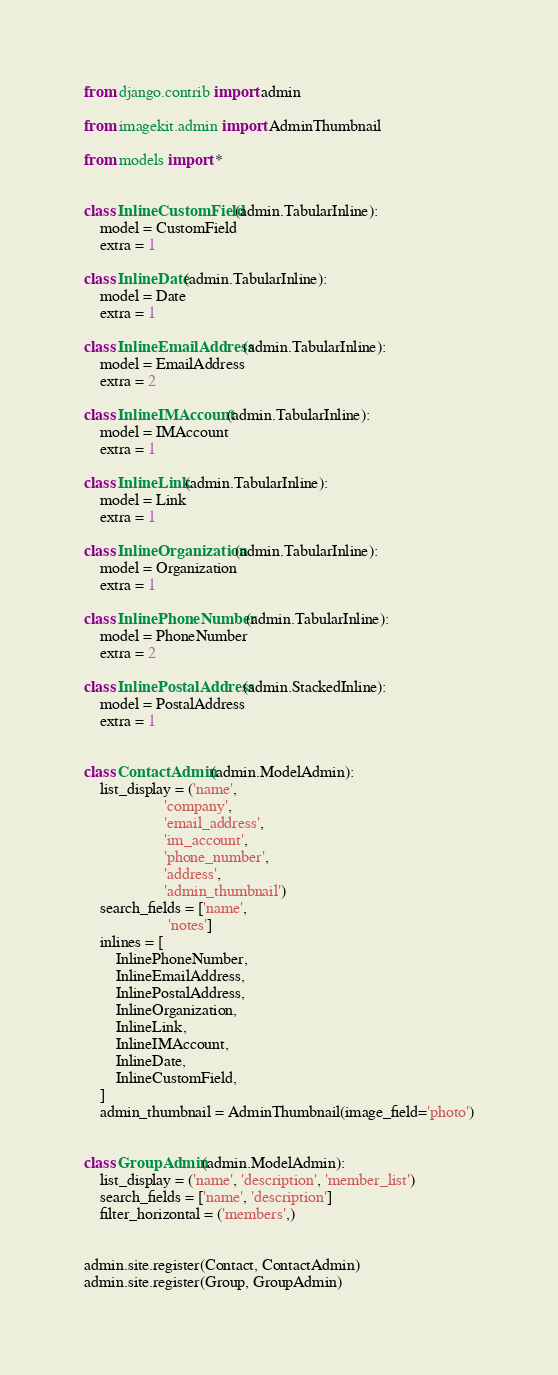Convert code to text. <code><loc_0><loc_0><loc_500><loc_500><_Python_>from django.contrib import admin

from imagekit.admin import AdminThumbnail

from models import *


class InlineCustomField(admin.TabularInline):
    model = CustomField
    extra = 1

class InlineDate(admin.TabularInline):
    model = Date
    extra = 1

class InlineEmailAddress(admin.TabularInline):
    model = EmailAddress
    extra = 2

class InlineIMAccount(admin.TabularInline):
    model = IMAccount
    extra = 1

class InlineLink(admin.TabularInline):
    model = Link
    extra = 1

class InlineOrganization(admin.TabularInline):
    model = Organization
    extra = 1

class InlinePhoneNumber(admin.TabularInline):
    model = PhoneNumber
    extra = 2

class InlinePostalAddress(admin.StackedInline):
    model = PostalAddress
    extra = 1


class ContactAdmin(admin.ModelAdmin):
    list_display = ('name',
                    'company',
                    'email_address',
                    'im_account',
                    'phone_number',
                    'address',
                    'admin_thumbnail')
    search_fields = ['name',
                     'notes']
    inlines = [
        InlinePhoneNumber,
        InlineEmailAddress,
        InlinePostalAddress,
        InlineOrganization,
        InlineLink,
        InlineIMAccount,
        InlineDate,
        InlineCustomField,
    ]
    admin_thumbnail = AdminThumbnail(image_field='photo')


class GroupAdmin(admin.ModelAdmin):
    list_display = ('name', 'description', 'member_list')
    search_fields = ['name', 'description']
    filter_horizontal = ('members',)


admin.site.register(Contact, ContactAdmin)
admin.site.register(Group, GroupAdmin)
</code> 